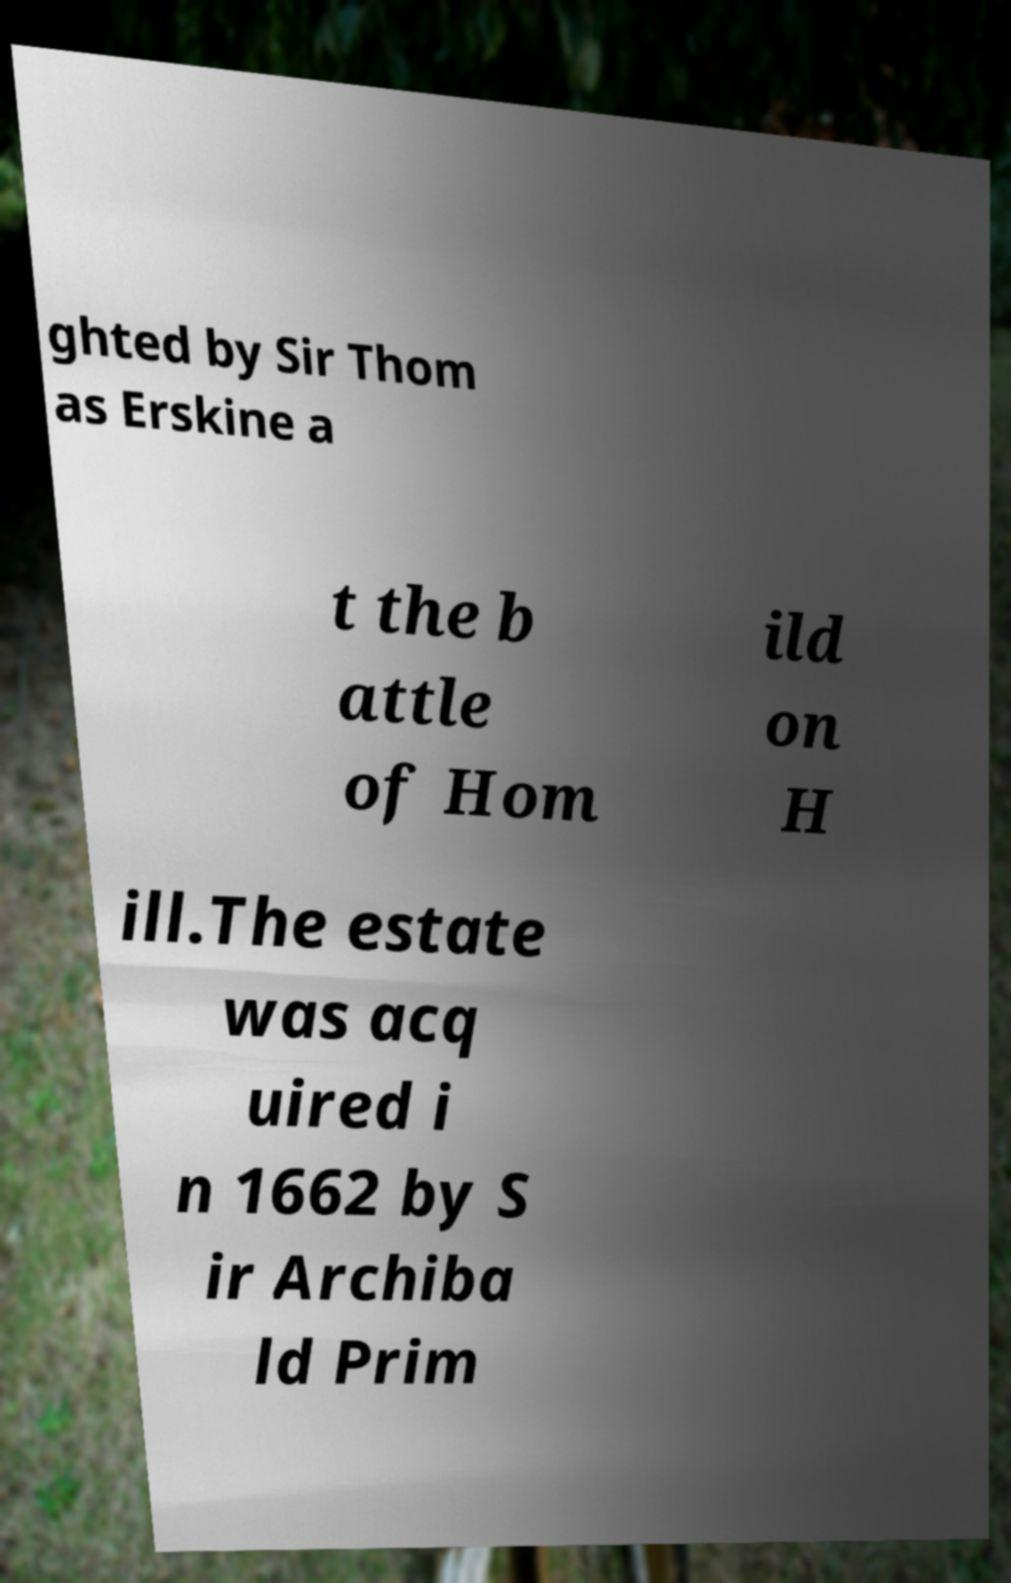There's text embedded in this image that I need extracted. Can you transcribe it verbatim? ghted by Sir Thom as Erskine a t the b attle of Hom ild on H ill.The estate was acq uired i n 1662 by S ir Archiba ld Prim 